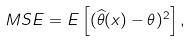<formula> <loc_0><loc_0><loc_500><loc_500>M S E = E \left [ ( { \widehat { \theta } } ( x ) - \theta ) ^ { 2 } \right ] ,</formula> 